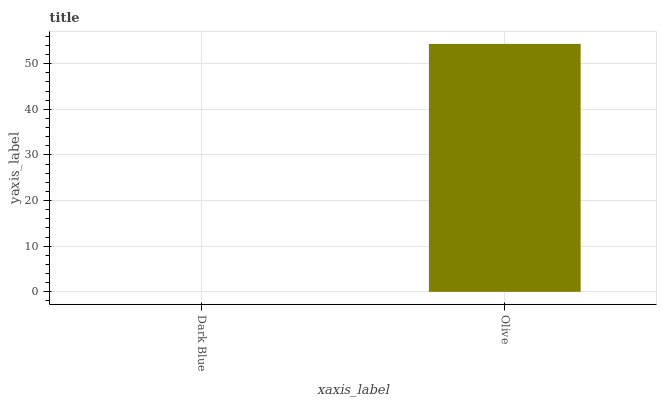Is Dark Blue the minimum?
Answer yes or no. Yes. Is Olive the maximum?
Answer yes or no. Yes. Is Olive the minimum?
Answer yes or no. No. Is Olive greater than Dark Blue?
Answer yes or no. Yes. Is Dark Blue less than Olive?
Answer yes or no. Yes. Is Dark Blue greater than Olive?
Answer yes or no. No. Is Olive less than Dark Blue?
Answer yes or no. No. Is Olive the high median?
Answer yes or no. Yes. Is Dark Blue the low median?
Answer yes or no. Yes. Is Dark Blue the high median?
Answer yes or no. No. Is Olive the low median?
Answer yes or no. No. 